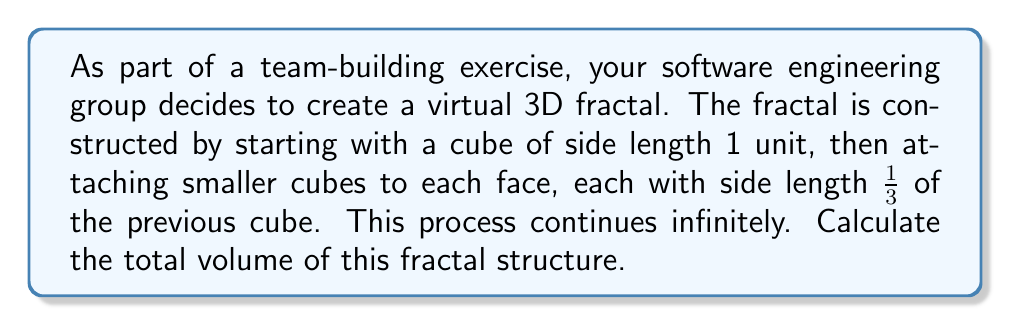Can you answer this question? Let's approach this step-by-step:

1) First, we need to identify the geometric series. In this case, we have:
   - Initial cube volume: $V_0 = 1^3 = 1$
   - First iteration: $V_1 = 6 \cdot (\frac{1}{3})^3 = \frac{6}{27}$
   - Second iteration: $V_2 = 6 \cdot 5 \cdot (\frac{1}{9})^3 = \frac{10}{243}$
   - And so on...

2) The general term of this series can be written as:
   $$V_n = 6 \cdot 5^{n-1} \cdot (\frac{1}{3^n})^3 = \frac{6 \cdot 5^{n-1}}{27^n}$$

3) The total volume is the sum of this infinite series:
   $$V_{total} = 1 + \sum_{n=1}^{\infty} \frac{6 \cdot 5^{n-1}}{27^n}$$

4) This is a geometric series with first term $a = \frac{6}{27}$ and common ratio $r = \frac{5}{27}$

5) For an infinite geometric series to converge, we need $|r| < 1$. Here, $|\frac{5}{27}| < 1$, so the series converges.

6) The sum of an infinite geometric series is given by $\frac{a}{1-r}$ where $a$ is the first term and $r$ is the common ratio.

7) Applying this formula:
   $$V_{total} = 1 + \frac{\frac{6}{27}}{1-\frac{5}{27}} = 1 + \frac{\frac{6}{27}}{\frac{22}{27}} = 1 + \frac{6}{22} = \frac{7}{3}$$

Therefore, the total volume of the fractal is $\frac{7}{3}$ cubic units.
Answer: $\frac{7}{3}$ cubic units 